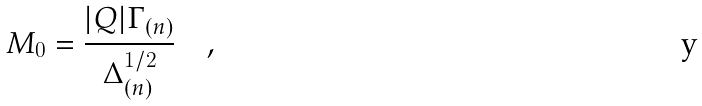<formula> <loc_0><loc_0><loc_500><loc_500>M _ { 0 } = \frac { | Q | \Gamma _ { ( n ) } } { \Delta _ { ( n ) } ^ { 1 / 2 } } \quad ,</formula> 